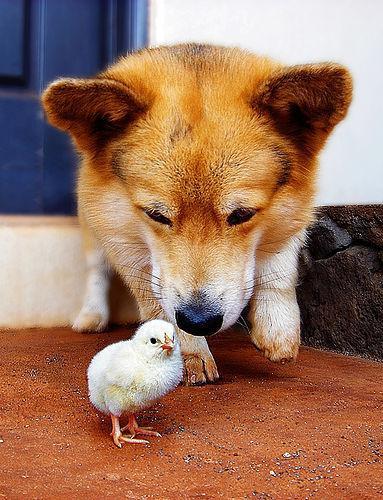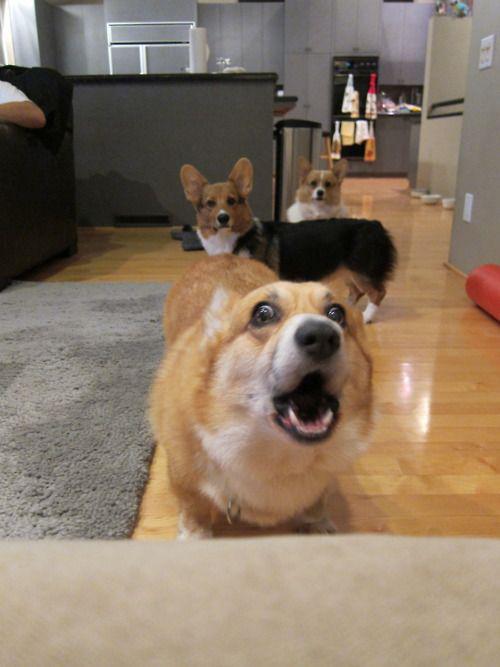The first image is the image on the left, the second image is the image on the right. For the images shown, is this caption "At least one hand is touching a dog, and at least one image contains a single dog with upright ears." true? Answer yes or no. No. The first image is the image on the left, the second image is the image on the right. Assess this claim about the two images: "There are more than four dogs.". Correct or not? Answer yes or no. No. 